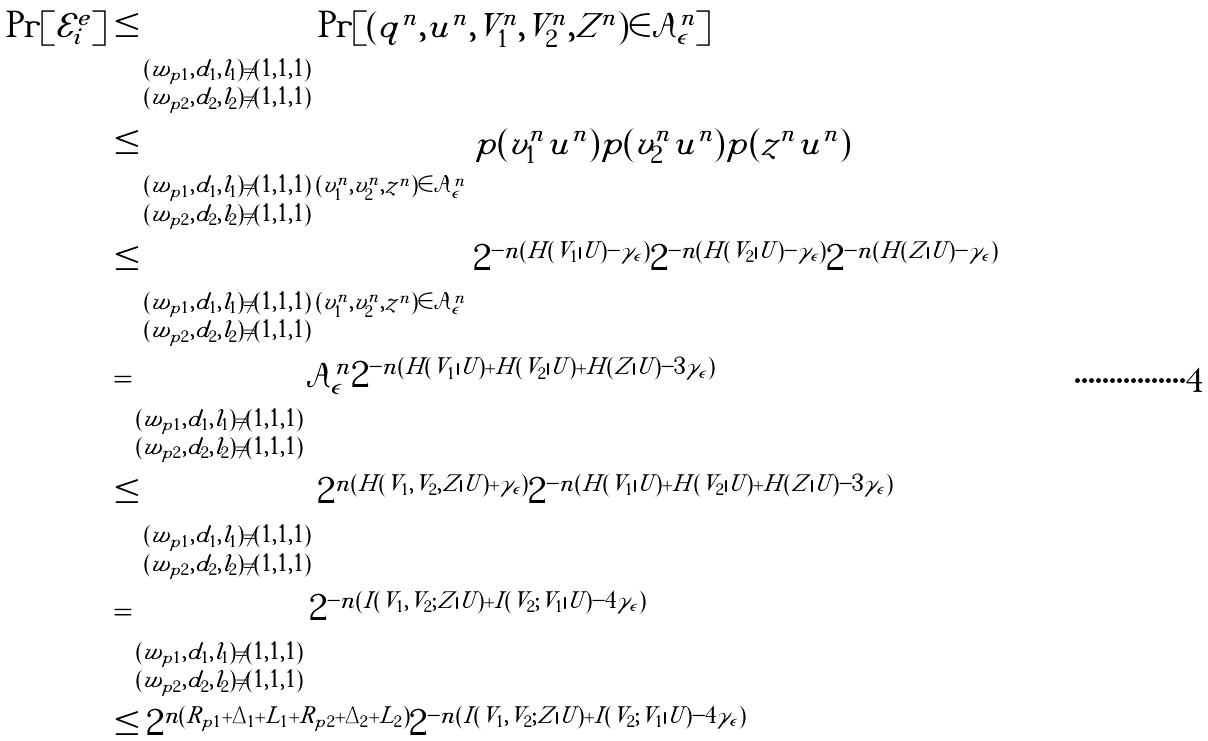<formula> <loc_0><loc_0><loc_500><loc_500>\Pr [ \mathcal { E } _ { i } ^ { e } ] & \leq \sum _ { \substack { ( w _ { p 1 } , d _ { 1 } , l _ { 1 } ) \neq ( 1 , 1 , 1 ) \\ ( w _ { p 2 } , d _ { 2 } , l _ { 2 } ) \neq ( 1 , 1 , 1 ) } } \Pr [ ( q ^ { n } , u ^ { n } , V _ { 1 } ^ { n } , V _ { 2 } ^ { n } , Z ^ { n } ) \in \mathcal { A } _ { \epsilon } ^ { n } ] \\ & \leq \sum _ { \substack { ( w _ { p 1 } , d _ { 1 } , l _ { 1 } ) \neq ( 1 , 1 , 1 ) \\ ( w _ { p 2 } , d _ { 2 } , l _ { 2 } ) \neq ( 1 , 1 , 1 ) } } \sum _ { ( v _ { 1 } ^ { n } , v _ { 2 } ^ { n } , z ^ { n } ) \in \mathcal { A } _ { \epsilon } ^ { n } } p ( v _ { 1 } ^ { n } | u ^ { n } ) p ( v _ { 2 } ^ { n } | u ^ { n } ) p ( z ^ { n } | u ^ { n } ) \\ & \leq \sum _ { \substack { ( w _ { p 1 } , d _ { 1 } , l _ { 1 } ) \neq ( 1 , 1 , 1 ) \\ ( w _ { p 2 } , d _ { 2 } , l _ { 2 } ) \neq ( 1 , 1 , 1 ) } } \sum _ { ( v _ { 1 } ^ { n } , v _ { 2 } ^ { n } , z ^ { n } ) \in \mathcal { A } _ { \epsilon } ^ { n } } 2 ^ { - n ( H ( V _ { 1 } | U ) - \gamma _ { \epsilon } ) } 2 ^ { - n ( H ( V _ { 2 } | U ) - \gamma _ { \epsilon } ) } 2 ^ { - n ( H ( Z | U ) - \gamma _ { \epsilon } ) } \\ & = \sum _ { \substack { ( w _ { p 1 } , d _ { 1 } , l _ { 1 } ) \neq ( 1 , 1 , 1 ) \\ ( w _ { p 2 } , d _ { 2 } , l _ { 2 } ) \neq ( 1 , 1 , 1 ) } } | \mathcal { A } _ { \epsilon } ^ { n } | 2 ^ { - n ( H ( V _ { 1 } | U ) + H ( V _ { 2 } | U ) + H ( Z | U ) - 3 \gamma _ { \epsilon } ) } \\ & \leq \sum _ { \substack { ( w _ { p 1 } , d _ { 1 } , l _ { 1 } ) \neq ( 1 , 1 , 1 ) \\ ( w _ { p 2 } , d _ { 2 } , l _ { 2 } ) \neq ( 1 , 1 , 1 ) } } 2 ^ { n ( H ( V _ { 1 } , V _ { 2 } , Z | U ) + \gamma _ { \epsilon } ) } 2 ^ { - n ( H ( V _ { 1 } | U ) + H ( V _ { 2 } | U ) + H ( Z | U ) - 3 \gamma _ { \epsilon } ) } \\ & = \sum _ { \substack { ( w _ { p 1 } , d _ { 1 } , l _ { 1 } ) \neq ( 1 , 1 , 1 ) \\ ( w _ { p 2 } , d _ { 2 } , l _ { 2 } ) \neq ( 1 , 1 , 1 ) } } 2 ^ { - n ( I ( V _ { 1 } , V _ { 2 } ; Z | U ) + I ( V _ { 2 } ; V _ { 1 } | U ) - 4 \gamma _ { \epsilon } ) } \\ & \leq 2 ^ { n ( R _ { p 1 } + \Delta _ { 1 } + L _ { 1 } + R _ { p 2 } + \Delta _ { 2 } + L _ { 2 } ) } 2 ^ { - n ( I ( V _ { 1 } , V _ { 2 } ; Z | U ) + I ( V _ { 2 } ; V _ { 1 } | U ) - 4 \gamma _ { \epsilon } ) }</formula> 